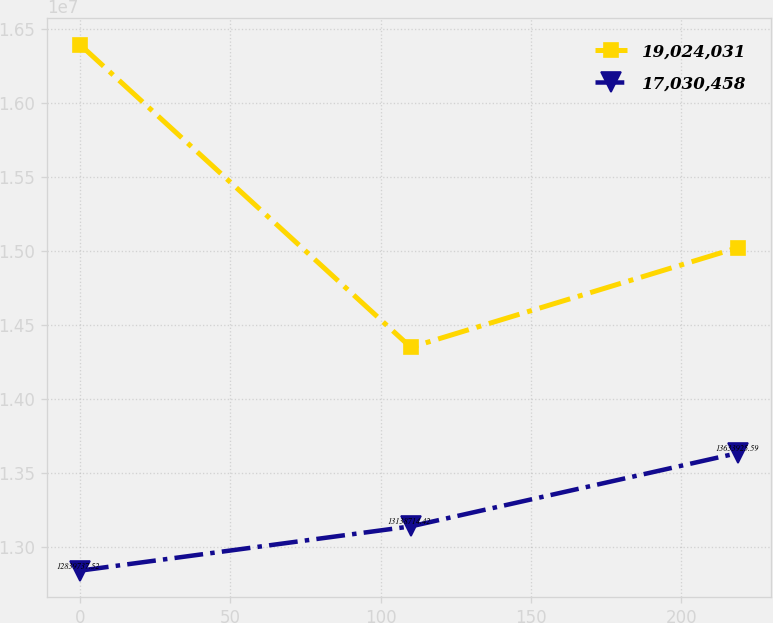<chart> <loc_0><loc_0><loc_500><loc_500><line_chart><ecel><fcel>19,024,031<fcel>17,030,458<nl><fcel>0<fcel>1.63917e+07<fcel>1.28397e+07<nl><fcel>110.02<fcel>1.43477e+07<fcel>1.31387e+07<nl><fcel>218.82<fcel>1.5021e+07<fcel>1.36339e+07<nl></chart> 